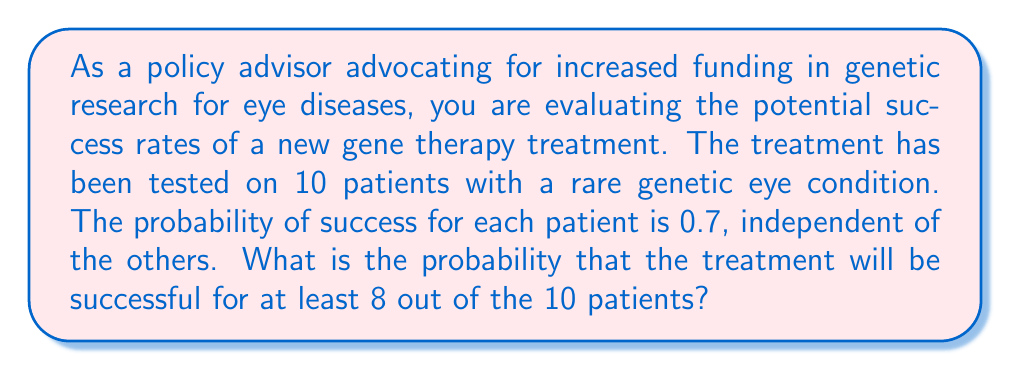Provide a solution to this math problem. To solve this problem, we need to use the binomial probability distribution. The scenario fits a binomial distribution because:
1. There are a fixed number of trials (10 patients)
2. Each trial has two possible outcomes (success or failure)
3. The probability of success is the same for each trial (0.7)
4. The trials are independent

We want to find the probability of 8, 9, or 10 successes out of 10 trials.

Let's use the binomial probability formula:

$$P(X = k) = \binom{n}{k} p^k (1-p)^{n-k}$$

Where:
$n$ = number of trials (10)
$k$ = number of successes
$p$ = probability of success (0.7)

We need to calculate:

$$P(X \geq 8) = P(X = 8) + P(X = 9) + P(X = 10)$$

For $k = 8$:
$$P(X = 8) = \binom{10}{8} (0.7)^8 (0.3)^2 = 45 \times 0.7^8 \times 0.3^2 = 0.2333$$

For $k = 9$:
$$P(X = 9) = \binom{10}{9} (0.7)^9 (0.3)^1 = 10 \times 0.7^9 \times 0.3^1 = 0.1211$$

For $k = 10$:
$$P(X = 10) = \binom{10}{10} (0.7)^{10} (0.3)^0 = 1 \times 0.7^{10} = 0.0282$$

Now, we sum these probabilities:

$$P(X \geq 8) = 0.2333 + 0.1211 + 0.0282 = 0.3826$$
Answer: The probability that the gene therapy treatment will be successful for at least 8 out of 10 patients is approximately 0.3826 or 38.26%. 